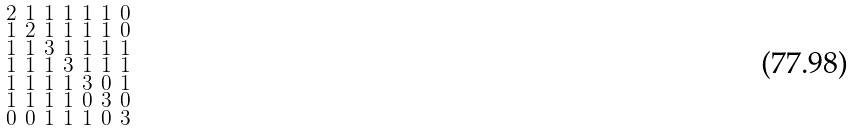Convert formula to latex. <formula><loc_0><loc_0><loc_500><loc_500>\begin{smallmatrix} 2 & 1 & 1 & 1 & 1 & 1 & 0 \\ 1 & 2 & 1 & 1 & 1 & 1 & 0 \\ 1 & 1 & 3 & 1 & 1 & 1 & 1 \\ 1 & 1 & 1 & 3 & 1 & 1 & 1 \\ 1 & 1 & 1 & 1 & 3 & 0 & 1 \\ 1 & 1 & 1 & 1 & 0 & 3 & 0 \\ 0 & 0 & 1 & 1 & 1 & 0 & 3 \end{smallmatrix}</formula> 